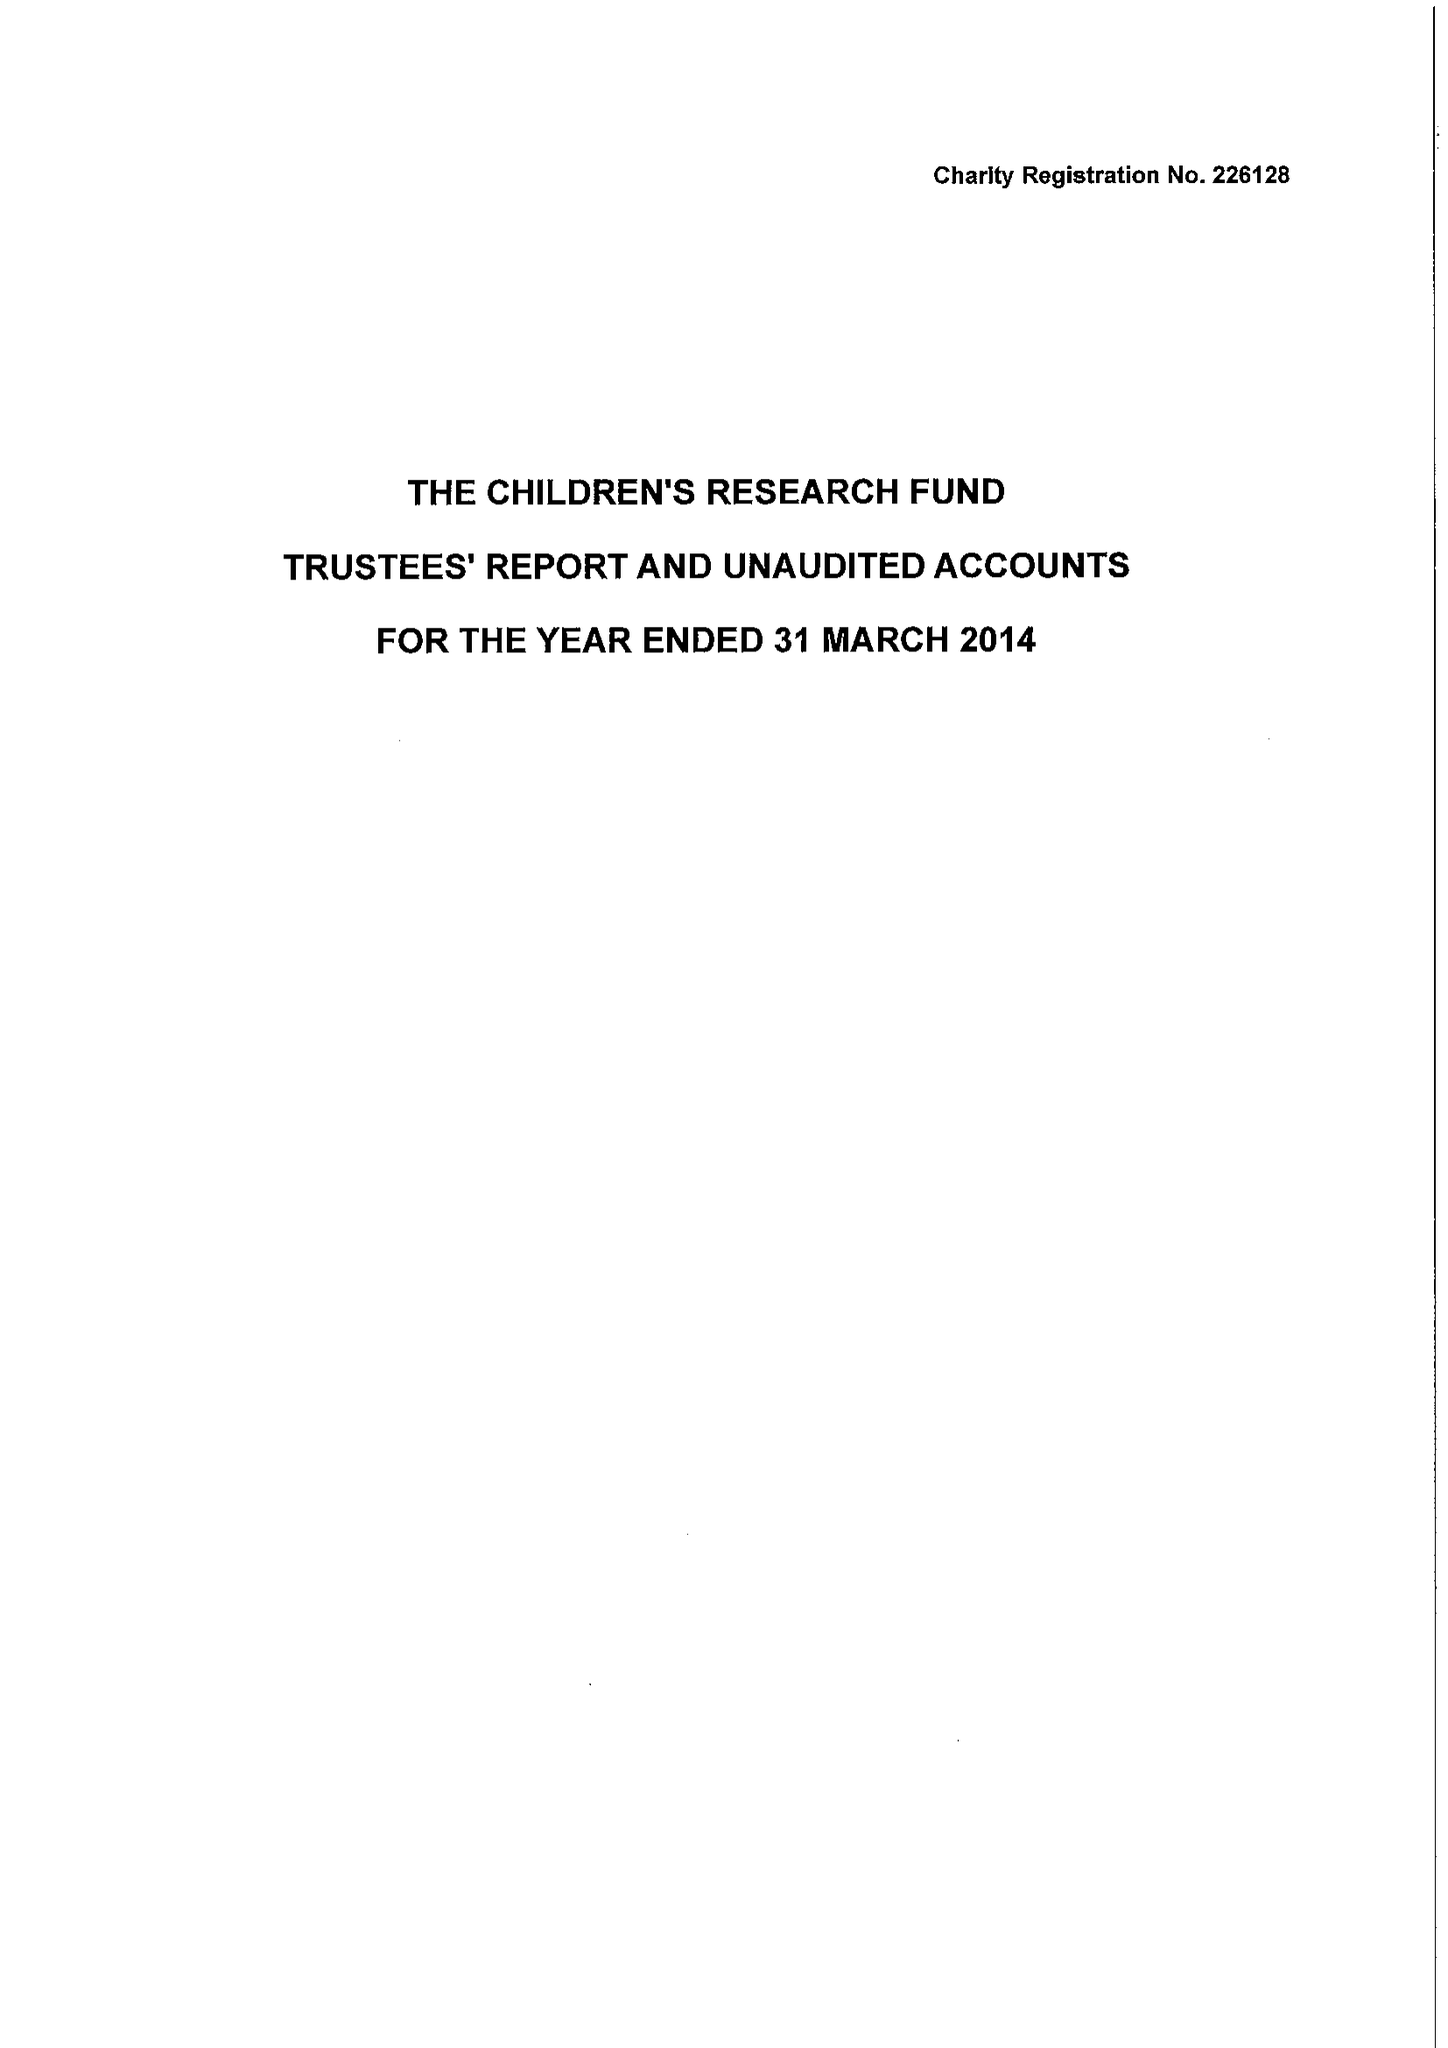What is the value for the report_date?
Answer the question using a single word or phrase. 2014-03-31 